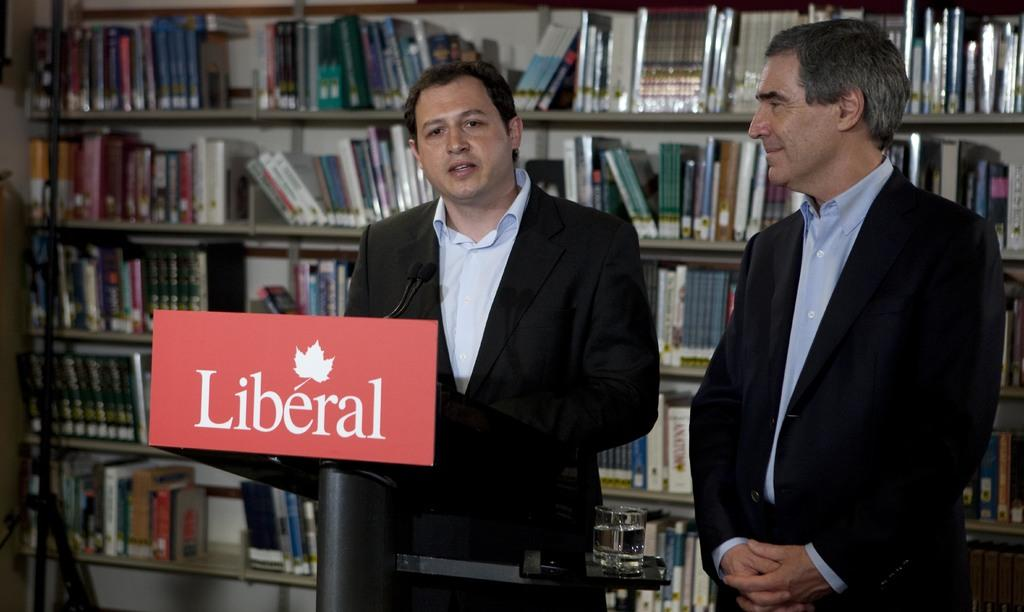What can be seen in the image involving people? There are people standing in the image. What is the board with text used for in the image? The board with text is likely used for communication or displaying information. What type of items are stored on the racks in the image? The racks are filled with books in the image. What type of pies are being served by the people in the image? There are no pies present in the image; it features people standing near a board with text and racks filled with books. 